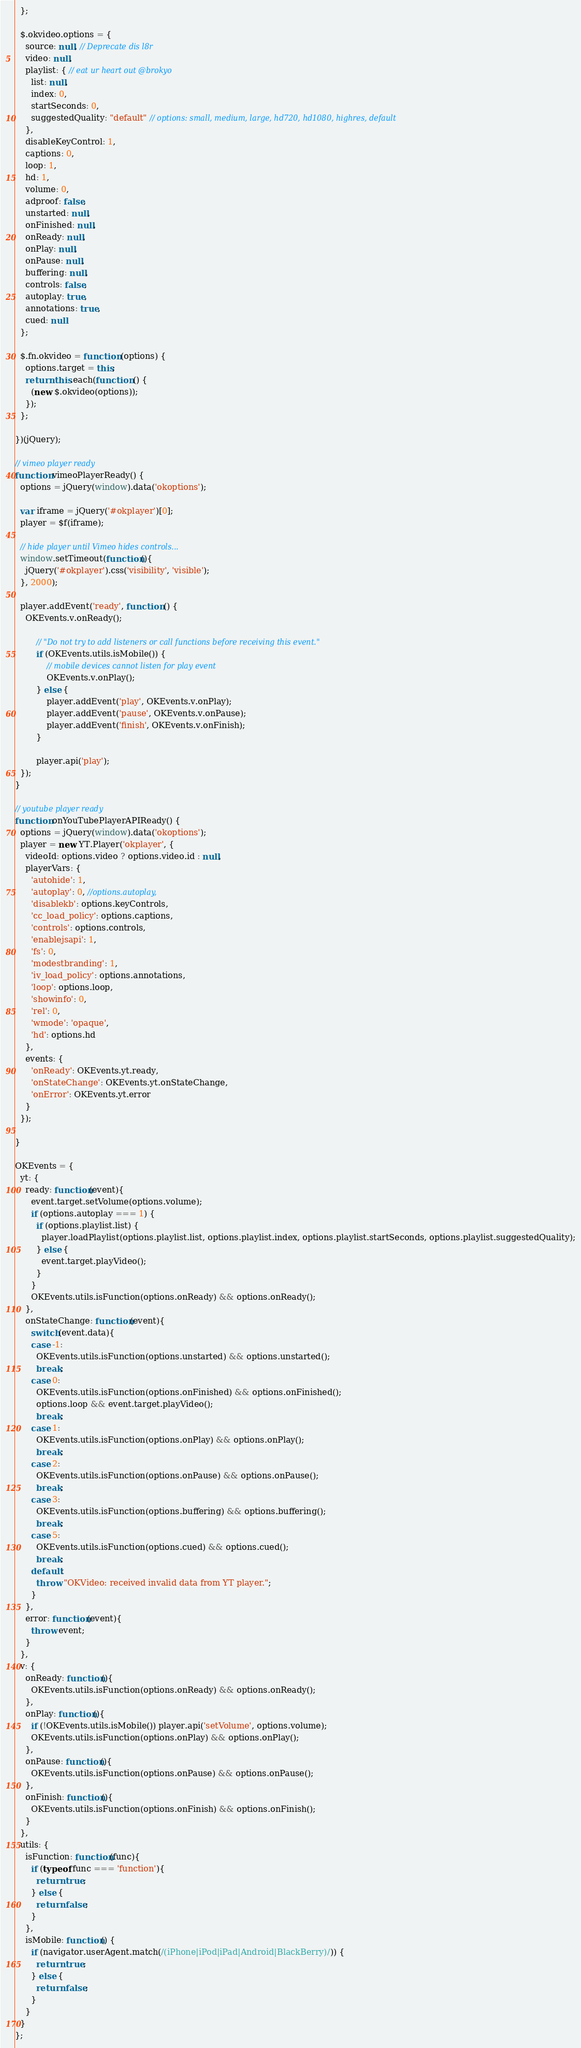Convert code to text. <code><loc_0><loc_0><loc_500><loc_500><_JavaScript_>  };

  $.okvideo.options = {
    source: null, // Deprecate dis l8r
    video: null,
    playlist: { // eat ur heart out @brokyo
      list: null,
      index: 0,
      startSeconds: 0,
      suggestedQuality: "default" // options: small, medium, large, hd720, hd1080, highres, default
    },
    disableKeyControl: 1,
    captions: 0,
    loop: 1,
    hd: 1,
    volume: 0,
    adproof: false,
    unstarted: null,
    onFinished: null,
    onReady: null,
    onPlay: null,
    onPause: null,
    buffering: null,
    controls: false,
    autoplay: true,
    annotations: true,
    cued: null
  };

  $.fn.okvideo = function (options) {
    options.target = this;
    return this.each(function () {
      (new $.okvideo(options));
    });
  };

})(jQuery);

// vimeo player ready
function vimeoPlayerReady() {
  options = jQuery(window).data('okoptions');

  var iframe = jQuery('#okplayer')[0];
  player = $f(iframe);

  // hide player until Vimeo hides controls...
  window.setTimeout(function(){
    jQuery('#okplayer').css('visibility', 'visible');
  }, 2000);

  player.addEvent('ready', function () {
    OKEvents.v.onReady();

		// "Do not try to add listeners or call functions before receiving this event."
		if (OKEvents.utils.isMobile()) {
			// mobile devices cannot listen for play event
			OKEvents.v.onPlay();
		} else {
			player.addEvent('play', OKEvents.v.onPlay);
			player.addEvent('pause', OKEvents.v.onPause);
			player.addEvent('finish', OKEvents.v.onFinish);
		}

		player.api('play');
  });
}

// youtube player ready
function onYouTubePlayerAPIReady() {
  options = jQuery(window).data('okoptions');
  player = new YT.Player('okplayer', {
    videoId: options.video ? options.video.id : null,
    playerVars: {
      'autohide': 1,
      'autoplay': 0, //options.autoplay,
      'disablekb': options.keyControls,
      'cc_load_policy': options.captions,
      'controls': options.controls,
      'enablejsapi': 1,
      'fs': 0,
      'modestbranding': 1,
      'iv_load_policy': options.annotations,
      'loop': options.loop,
      'showinfo': 0,
      'rel': 0,
      'wmode': 'opaque',
      'hd': options.hd
    },
    events: {
      'onReady': OKEvents.yt.ready,
      'onStateChange': OKEvents.yt.onStateChange,
      'onError': OKEvents.yt.error
    }
  });

}

OKEvents = {
  yt: {
    ready: function(event){
      event.target.setVolume(options.volume);
      if (options.autoplay === 1) {
        if (options.playlist.list) {
          player.loadPlaylist(options.playlist.list, options.playlist.index, options.playlist.startSeconds, options.playlist.suggestedQuality);
        } else {
          event.target.playVideo();
        }
      }
      OKEvents.utils.isFunction(options.onReady) && options.onReady();
    },
    onStateChange: function(event){
      switch(event.data){
      case -1:
        OKEvents.utils.isFunction(options.unstarted) && options.unstarted();
        break;
      case 0:
        OKEvents.utils.isFunction(options.onFinished) && options.onFinished();
        options.loop && event.target.playVideo();
        break;
      case 1:
        OKEvents.utils.isFunction(options.onPlay) && options.onPlay();
        break;
      case 2:
        OKEvents.utils.isFunction(options.onPause) && options.onPause();
        break;
      case 3:
        OKEvents.utils.isFunction(options.buffering) && options.buffering();
        break;
      case 5:
        OKEvents.utils.isFunction(options.cued) && options.cued();
        break;
      default:
        throw "OKVideo: received invalid data from YT player.";
      }
    },
    error: function(event){
      throw event;
    }
  },
  v: {
    onReady: function(){
      OKEvents.utils.isFunction(options.onReady) && options.onReady();
    },
    onPlay: function(){
      if (!OKEvents.utils.isMobile()) player.api('setVolume', options.volume);
      OKEvents.utils.isFunction(options.onPlay) && options.onPlay();
    },
    onPause: function(){
      OKEvents.utils.isFunction(options.onPause) && options.onPause();
    },
    onFinish: function(){
      OKEvents.utils.isFunction(options.onFinish) && options.onFinish();
    }
  },
  utils: {
    isFunction: function(func){
      if (typeof func === 'function'){
        return true;
      } else {
        return false;
      }
    },
    isMobile: function() {
      if (navigator.userAgent.match(/(iPhone|iPod|iPad|Android|BlackBerry)/)) {
        return true;
      } else {
        return false;
      }
    }
  }
};
</code> 